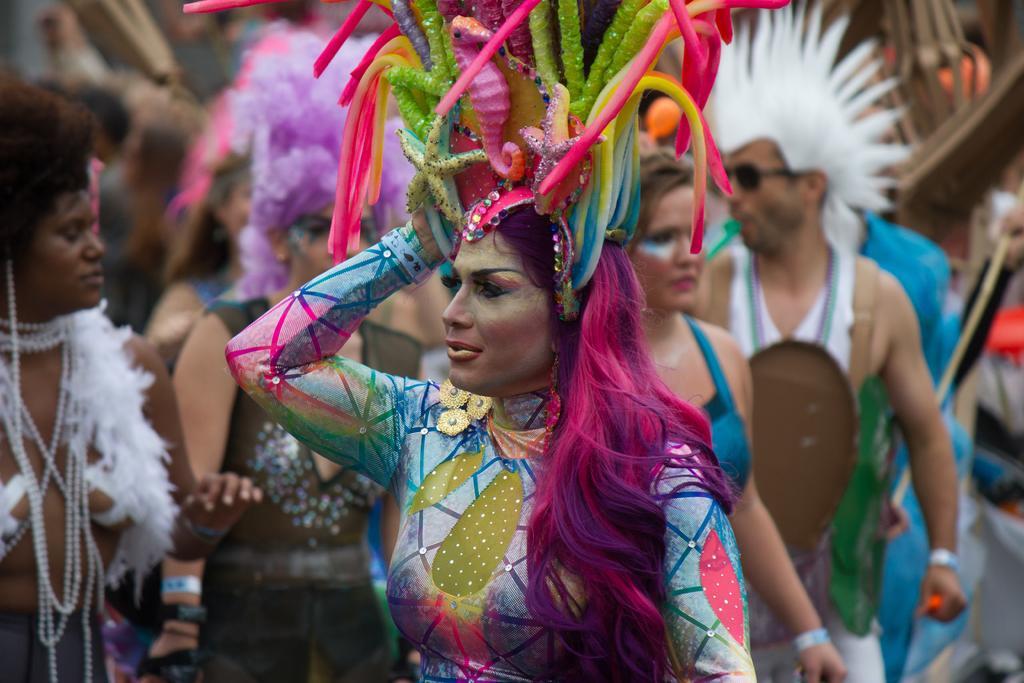Could you give a brief overview of what you see in this image? In the picture we can see some women and men are standing in different costumes. 